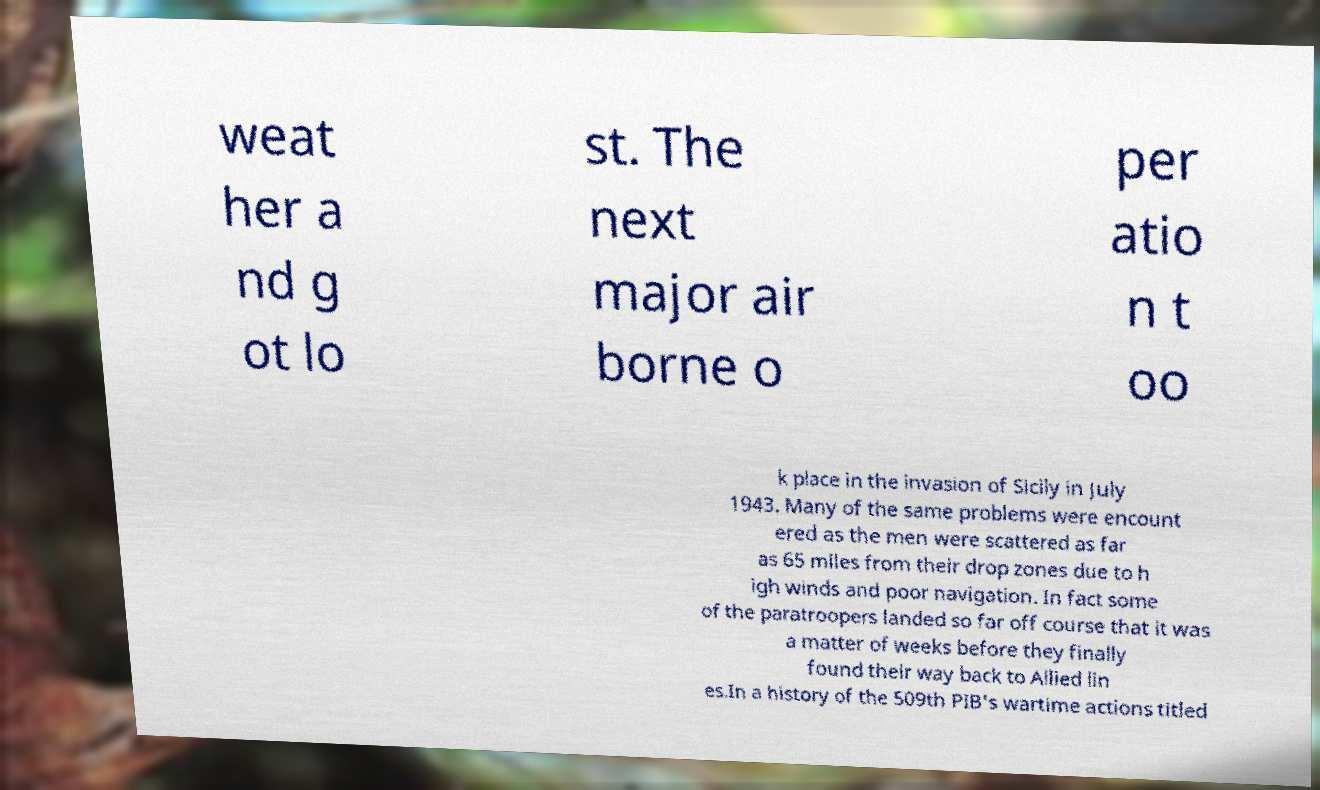Please identify and transcribe the text found in this image. weat her a nd g ot lo st. The next major air borne o per atio n t oo k place in the invasion of Sicily in July 1943. Many of the same problems were encount ered as the men were scattered as far as 65 miles from their drop zones due to h igh winds and poor navigation. In fact some of the paratroopers landed so far off course that it was a matter of weeks before they finally found their way back to Allied lin es.In a history of the 509th PIB's wartime actions titled 